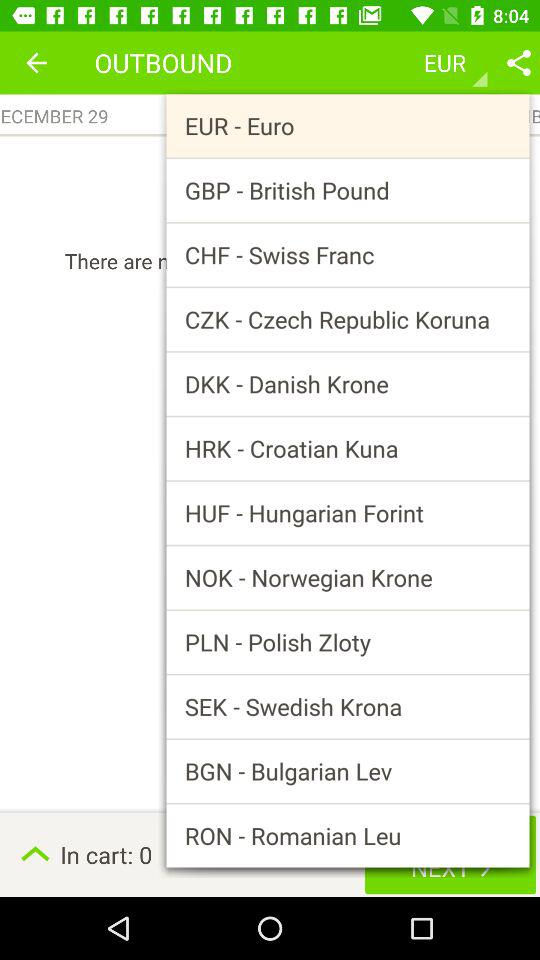What is the number of items in the cart? The number of items in the cart is 0. 